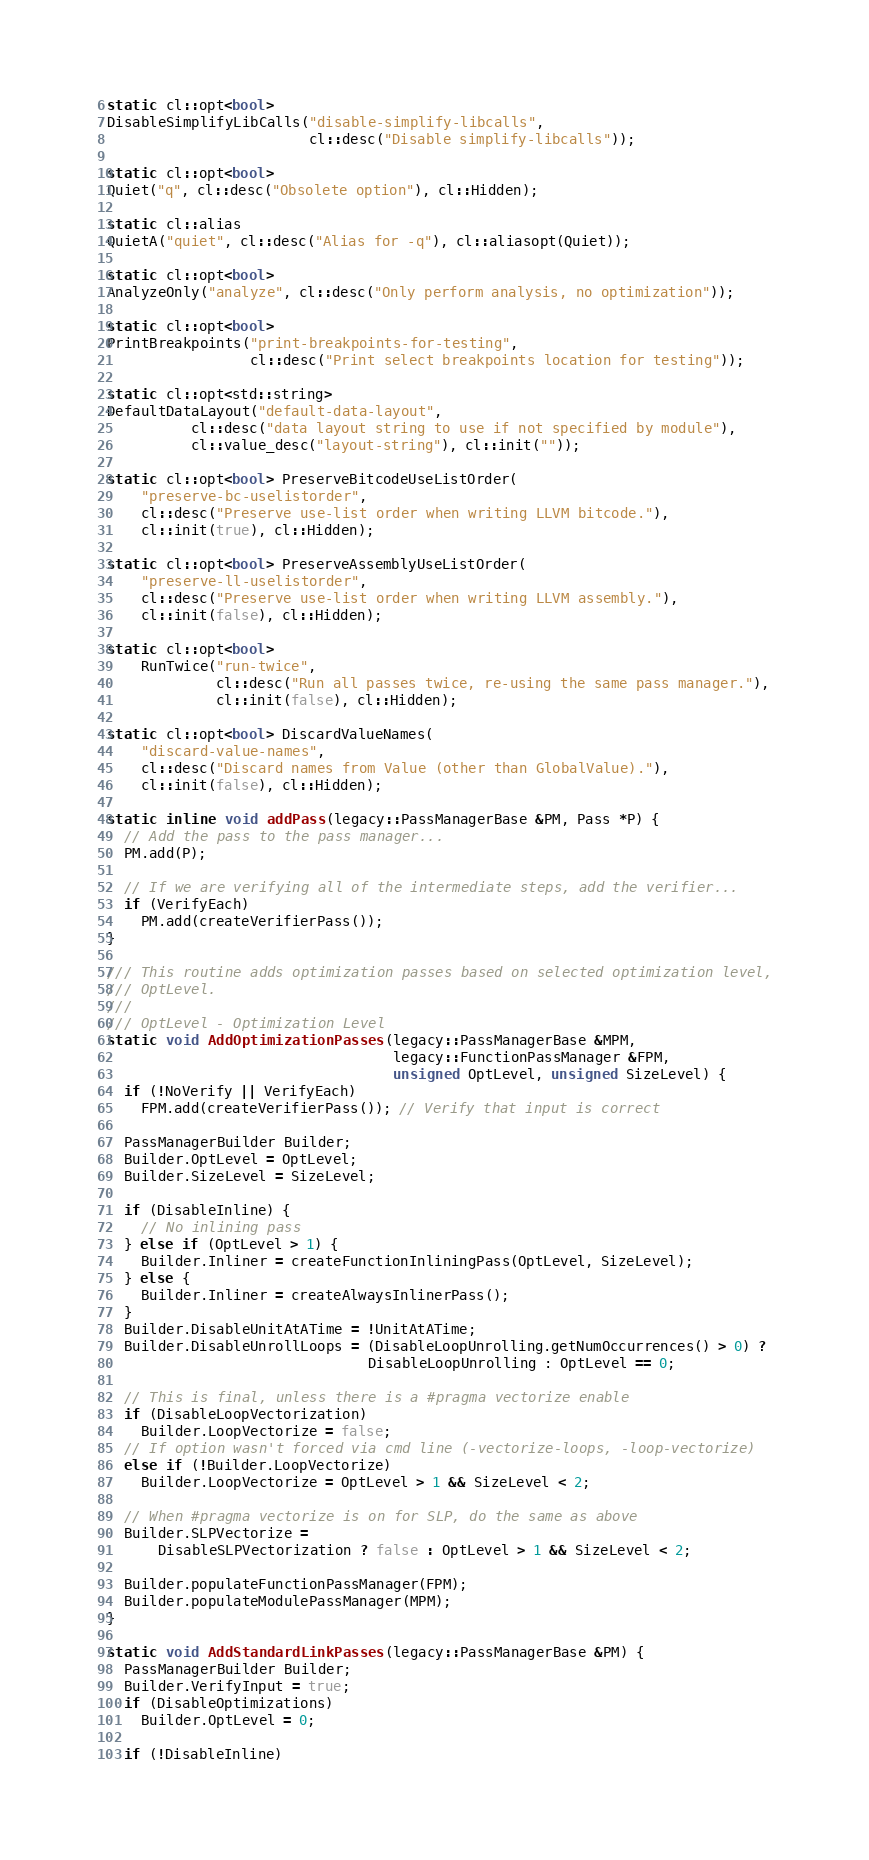<code> <loc_0><loc_0><loc_500><loc_500><_C++_>

static cl::opt<bool>
DisableSimplifyLibCalls("disable-simplify-libcalls",
                        cl::desc("Disable simplify-libcalls"));

static cl::opt<bool>
Quiet("q", cl::desc("Obsolete option"), cl::Hidden);

static cl::alias
QuietA("quiet", cl::desc("Alias for -q"), cl::aliasopt(Quiet));

static cl::opt<bool>
AnalyzeOnly("analyze", cl::desc("Only perform analysis, no optimization"));

static cl::opt<bool>
PrintBreakpoints("print-breakpoints-for-testing",
                 cl::desc("Print select breakpoints location for testing"));

static cl::opt<std::string>
DefaultDataLayout("default-data-layout",
          cl::desc("data layout string to use if not specified by module"),
          cl::value_desc("layout-string"), cl::init(""));

static cl::opt<bool> PreserveBitcodeUseListOrder(
    "preserve-bc-uselistorder",
    cl::desc("Preserve use-list order when writing LLVM bitcode."),
    cl::init(true), cl::Hidden);

static cl::opt<bool> PreserveAssemblyUseListOrder(
    "preserve-ll-uselistorder",
    cl::desc("Preserve use-list order when writing LLVM assembly."),
    cl::init(false), cl::Hidden);

static cl::opt<bool>
    RunTwice("run-twice",
             cl::desc("Run all passes twice, re-using the same pass manager."),
             cl::init(false), cl::Hidden);

static cl::opt<bool> DiscardValueNames(
    "discard-value-names",
    cl::desc("Discard names from Value (other than GlobalValue)."),
    cl::init(false), cl::Hidden);

static inline void addPass(legacy::PassManagerBase &PM, Pass *P) {
  // Add the pass to the pass manager...
  PM.add(P);

  // If we are verifying all of the intermediate steps, add the verifier...
  if (VerifyEach)
    PM.add(createVerifierPass());
}

/// This routine adds optimization passes based on selected optimization level,
/// OptLevel.
///
/// OptLevel - Optimization Level
static void AddOptimizationPasses(legacy::PassManagerBase &MPM,
                                  legacy::FunctionPassManager &FPM,
                                  unsigned OptLevel, unsigned SizeLevel) {
  if (!NoVerify || VerifyEach)
    FPM.add(createVerifierPass()); // Verify that input is correct

  PassManagerBuilder Builder;
  Builder.OptLevel = OptLevel;
  Builder.SizeLevel = SizeLevel;

  if (DisableInline) {
    // No inlining pass
  } else if (OptLevel > 1) {
    Builder.Inliner = createFunctionInliningPass(OptLevel, SizeLevel);
  } else {
    Builder.Inliner = createAlwaysInlinerPass();
  }
  Builder.DisableUnitAtATime = !UnitAtATime;
  Builder.DisableUnrollLoops = (DisableLoopUnrolling.getNumOccurrences() > 0) ?
                               DisableLoopUnrolling : OptLevel == 0;

  // This is final, unless there is a #pragma vectorize enable
  if (DisableLoopVectorization)
    Builder.LoopVectorize = false;
  // If option wasn't forced via cmd line (-vectorize-loops, -loop-vectorize)
  else if (!Builder.LoopVectorize)
    Builder.LoopVectorize = OptLevel > 1 && SizeLevel < 2;

  // When #pragma vectorize is on for SLP, do the same as above
  Builder.SLPVectorize =
      DisableSLPVectorization ? false : OptLevel > 1 && SizeLevel < 2;

  Builder.populateFunctionPassManager(FPM);
  Builder.populateModulePassManager(MPM);
}

static void AddStandardLinkPasses(legacy::PassManagerBase &PM) {
  PassManagerBuilder Builder;
  Builder.VerifyInput = true;
  if (DisableOptimizations)
    Builder.OptLevel = 0;

  if (!DisableInline)</code> 